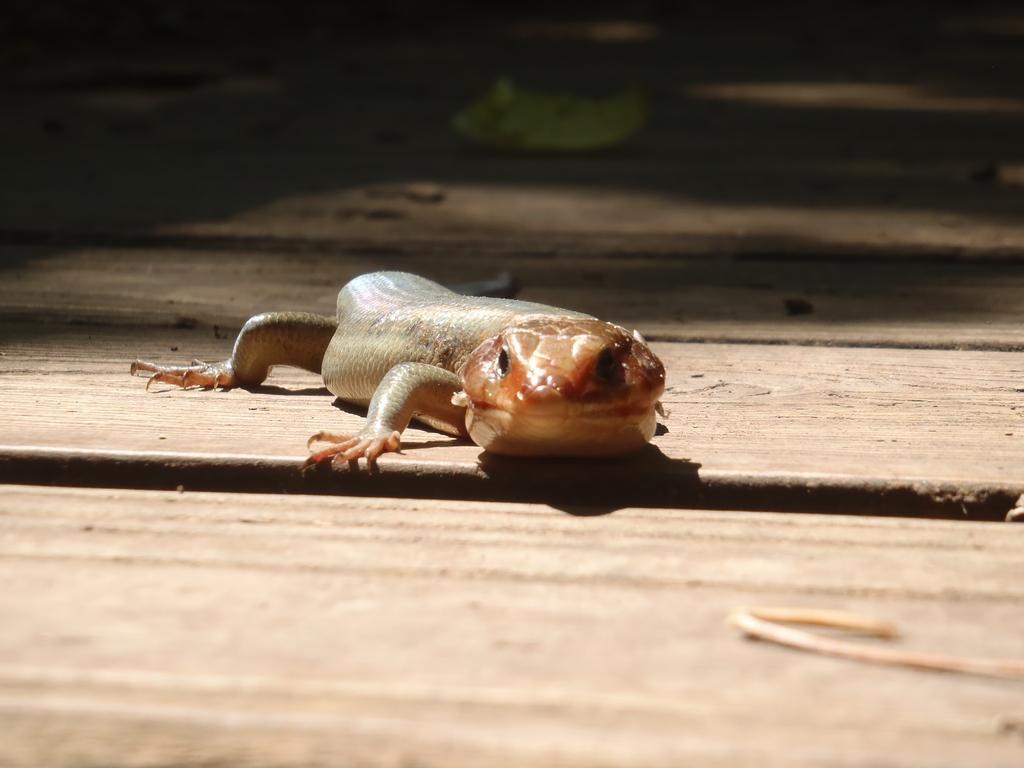Can you describe this image briefly? This image consists of a lizard on the floor. The floor is made up of wood. The background is dark. 